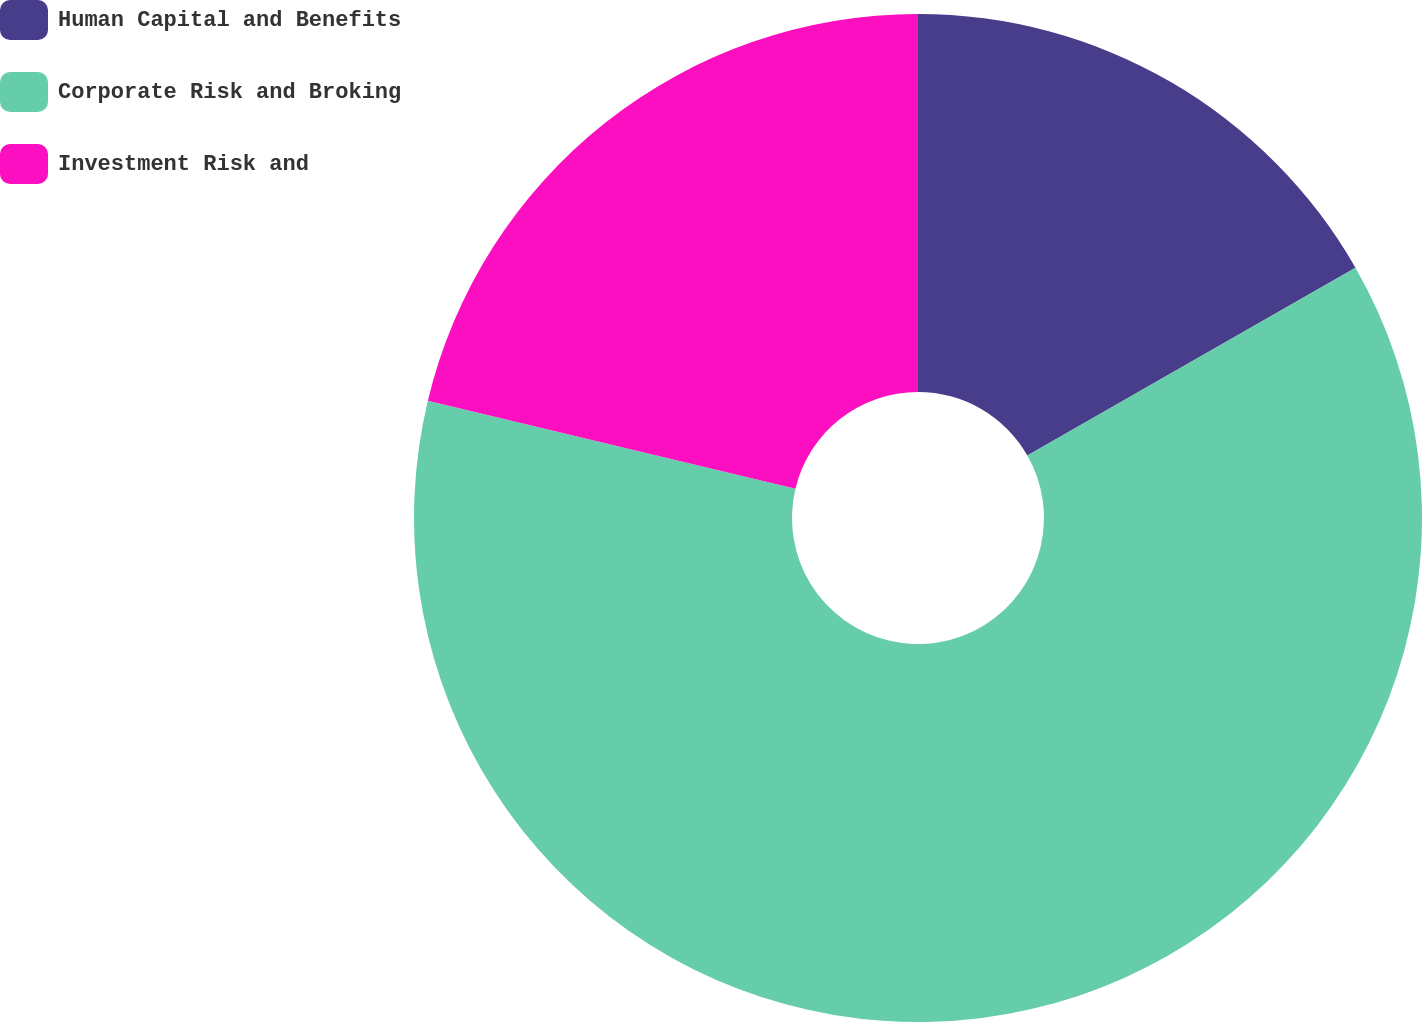Convert chart. <chart><loc_0><loc_0><loc_500><loc_500><pie_chart><fcel>Human Capital and Benefits<fcel>Corporate Risk and Broking<fcel>Investment Risk and<nl><fcel>16.73%<fcel>62.01%<fcel>21.26%<nl></chart> 